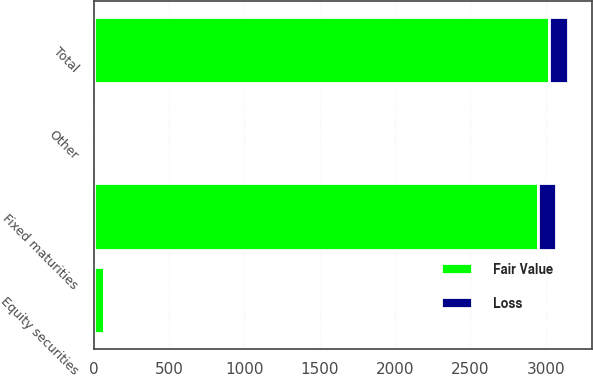Convert chart to OTSL. <chart><loc_0><loc_0><loc_500><loc_500><stacked_bar_chart><ecel><fcel>Fixed maturities<fcel>Equity securities<fcel>Other<fcel>Total<nl><fcel>Loss<fcel>121<fcel>6<fcel>1<fcel>128<nl><fcel>Fair Value<fcel>2950<fcel>69<fcel>1<fcel>3020<nl></chart> 